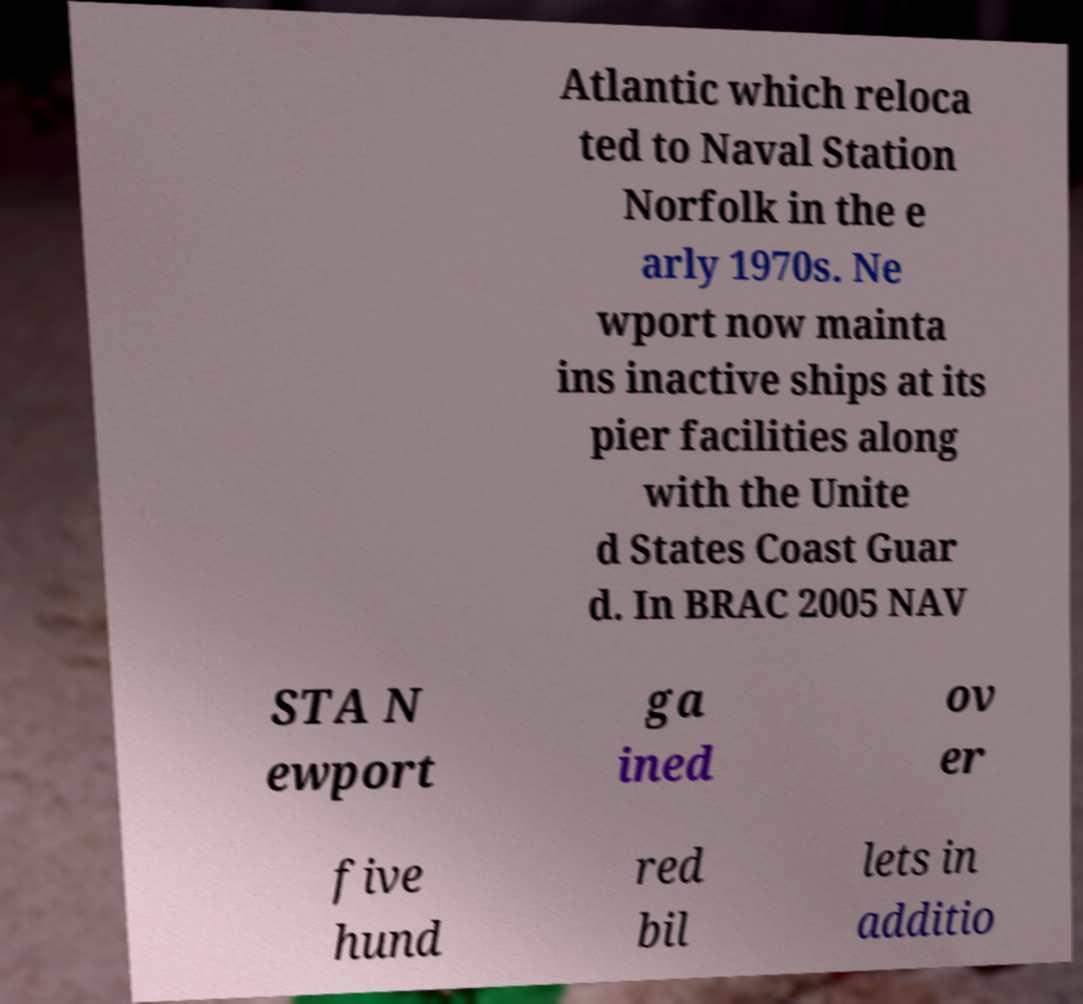Can you read and provide the text displayed in the image?This photo seems to have some interesting text. Can you extract and type it out for me? Atlantic which reloca ted to Naval Station Norfolk in the e arly 1970s. Ne wport now mainta ins inactive ships at its pier facilities along with the Unite d States Coast Guar d. In BRAC 2005 NAV STA N ewport ga ined ov er five hund red bil lets in additio 